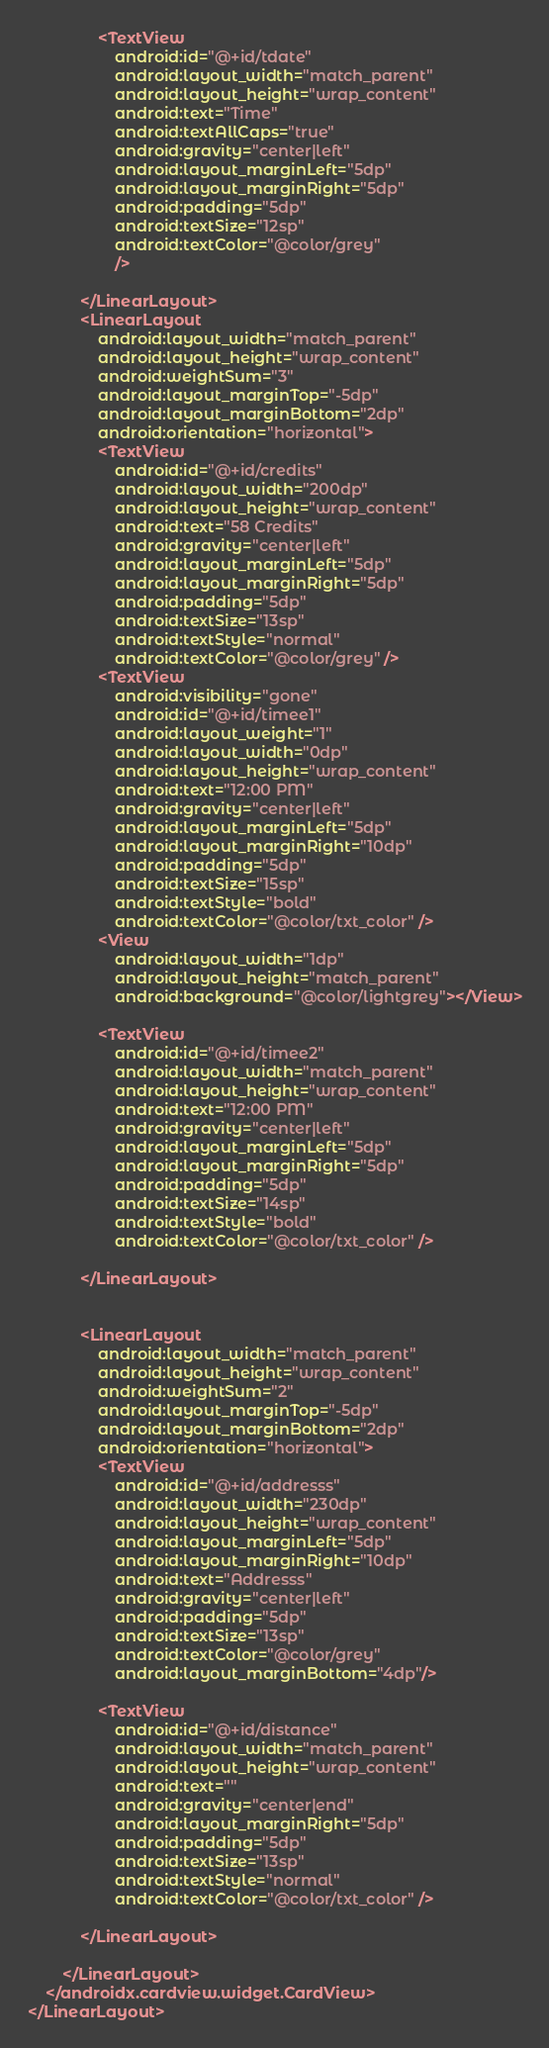<code> <loc_0><loc_0><loc_500><loc_500><_XML_>                <TextView
                    android:id="@+id/tdate"
                    android:layout_width="match_parent"
                    android:layout_height="wrap_content"
                    android:text="Time"
                    android:textAllCaps="true"
                    android:gravity="center|left"
                    android:layout_marginLeft="5dp"
                    android:layout_marginRight="5dp"
                    android:padding="5dp"
                    android:textSize="12sp"
                    android:textColor="@color/grey"
                    />

            </LinearLayout>
            <LinearLayout
                android:layout_width="match_parent"
                android:layout_height="wrap_content"
                android:weightSum="3"
                android:layout_marginTop="-5dp"
                android:layout_marginBottom="2dp"
                android:orientation="horizontal">
                <TextView
                    android:id="@+id/credits"
                    android:layout_width="200dp"
                    android:layout_height="wrap_content"
                    android:text="58 Credits"
                    android:gravity="center|left"
                    android:layout_marginLeft="5dp"
                    android:layout_marginRight="5dp"
                    android:padding="5dp"
                    android:textSize="13sp"
                    android:textStyle="normal"
                    android:textColor="@color/grey" />
                <TextView
                    android:visibility="gone"
                    android:id="@+id/timee1"
                    android:layout_weight="1"
                    android:layout_width="0dp"
                    android:layout_height="wrap_content"
                    android:text="12:00 PM"
                    android:gravity="center|left"
                    android:layout_marginLeft="5dp"
                    android:layout_marginRight="10dp"
                    android:padding="5dp"
                    android:textSize="15sp"
                    android:textStyle="bold"
                    android:textColor="@color/txt_color" />
                <View
                    android:layout_width="1dp"
                    android:layout_height="match_parent"
                    android:background="@color/lightgrey"></View>

                <TextView
                    android:id="@+id/timee2"
                    android:layout_width="match_parent"
                    android:layout_height="wrap_content"
                    android:text="12:00 PM"
                    android:gravity="center|left"
                    android:layout_marginLeft="5dp"
                    android:layout_marginRight="5dp"
                    android:padding="5dp"
                    android:textSize="14sp"
                    android:textStyle="bold"
                    android:textColor="@color/txt_color" />

            </LinearLayout>


            <LinearLayout
                android:layout_width="match_parent"
                android:layout_height="wrap_content"
                android:weightSum="2"
                android:layout_marginTop="-5dp"
                android:layout_marginBottom="2dp"
                android:orientation="horizontal">
                <TextView
                    android:id="@+id/addresss"
                    android:layout_width="230dp"
                    android:layout_height="wrap_content"
                    android:layout_marginLeft="5dp"
                    android:layout_marginRight="10dp"
                    android:text="Addresss"
                    android:gravity="center|left"
                    android:padding="5dp"
                    android:textSize="13sp"
                    android:textColor="@color/grey"
                    android:layout_marginBottom="4dp"/>

                <TextView
                    android:id="@+id/distance"
                    android:layout_width="match_parent"
                    android:layout_height="wrap_content"
                    android:text=""
                    android:gravity="center|end"
                    android:layout_marginRight="5dp"
                    android:padding="5dp"
                    android:textSize="13sp"
                    android:textStyle="normal"
                    android:textColor="@color/txt_color" />

            </LinearLayout>

        </LinearLayout>
    </androidx.cardview.widget.CardView>
</LinearLayout>
</code> 